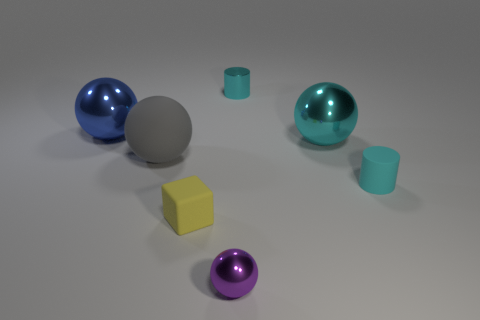Subtract 1 balls. How many balls are left? 3 Add 1 blue spheres. How many objects exist? 8 Subtract all blocks. How many objects are left? 6 Add 2 large cyan objects. How many large cyan objects exist? 3 Subtract 0 cyan cubes. How many objects are left? 7 Subtract all tiny blue matte objects. Subtract all yellow cubes. How many objects are left? 6 Add 5 large cyan balls. How many large cyan balls are left? 6 